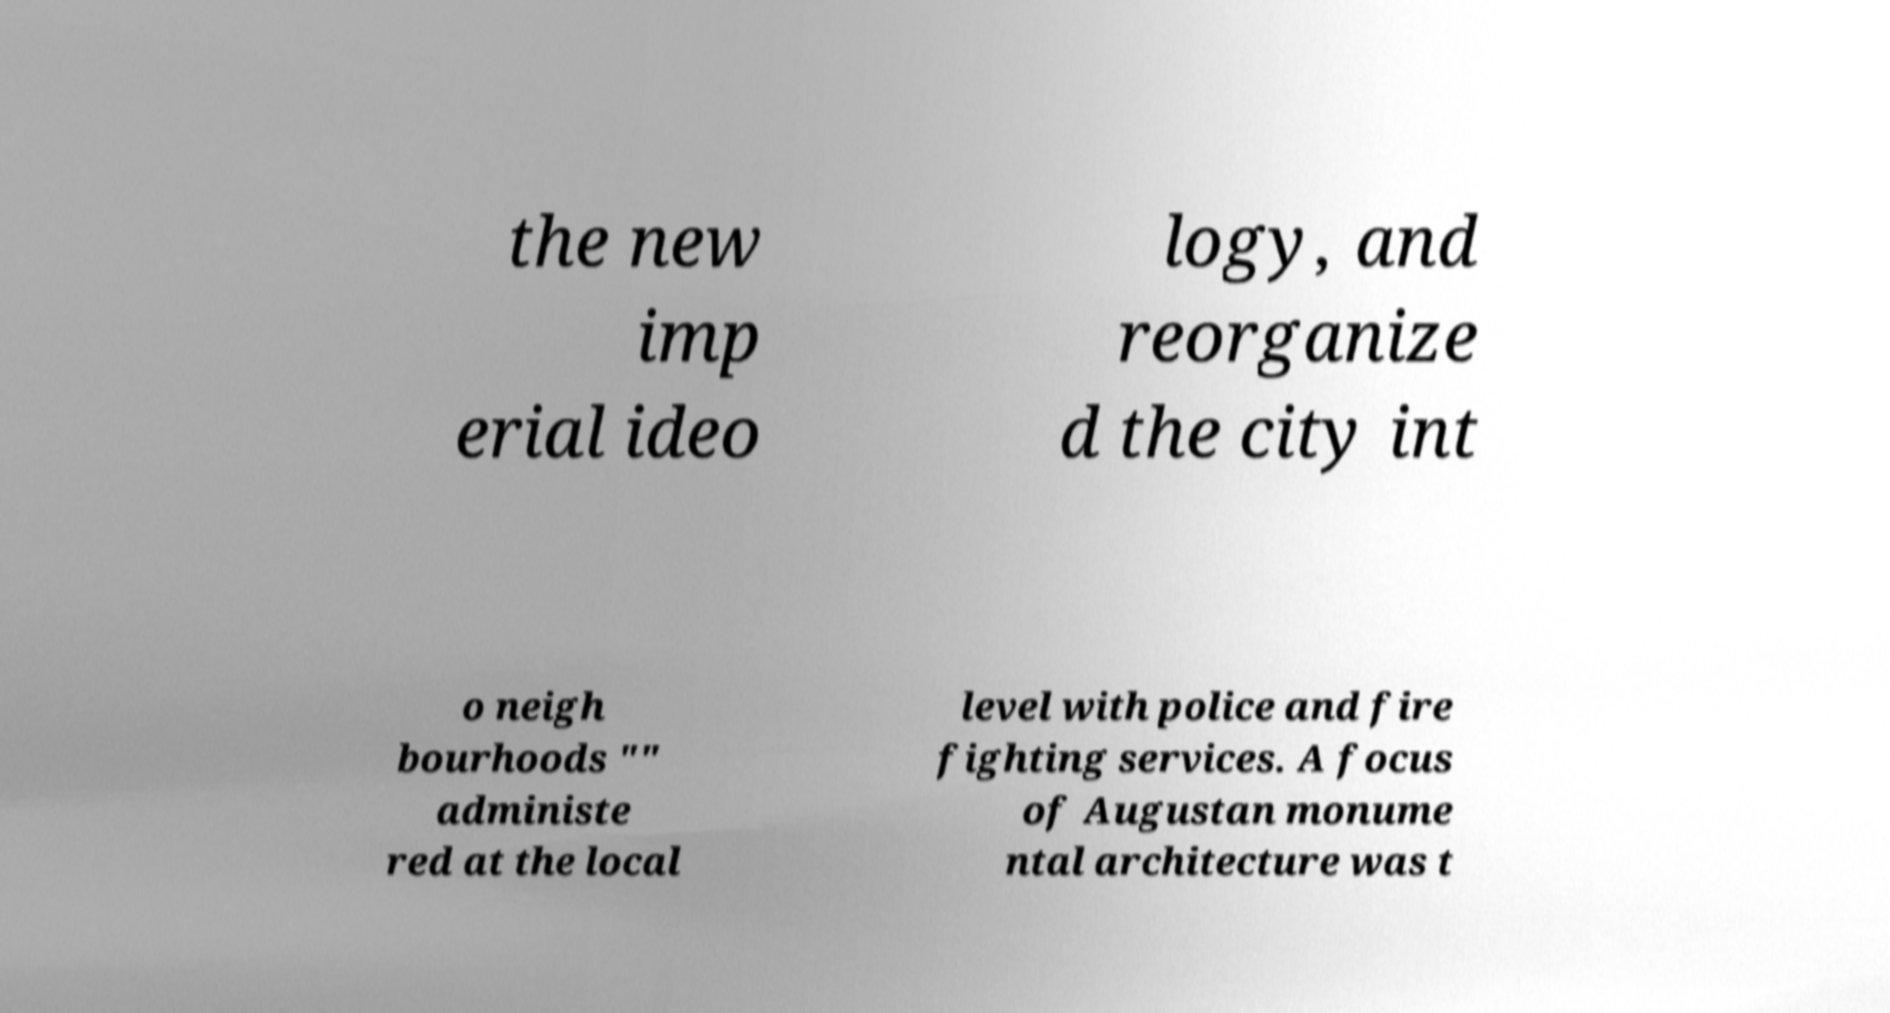Could you assist in decoding the text presented in this image and type it out clearly? the new imp erial ideo logy, and reorganize d the city int o neigh bourhoods "" administe red at the local level with police and fire fighting services. A focus of Augustan monume ntal architecture was t 